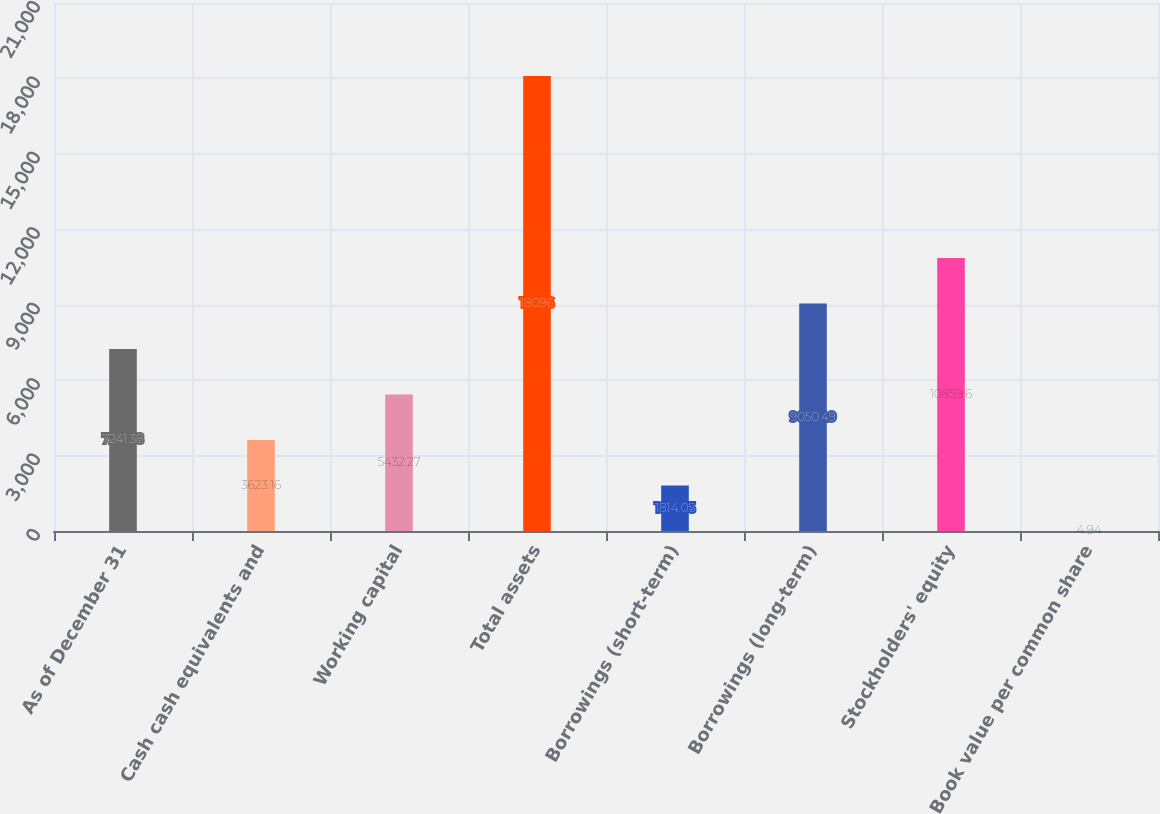Convert chart to OTSL. <chart><loc_0><loc_0><loc_500><loc_500><bar_chart><fcel>As of December 31<fcel>Cash cash equivalents and<fcel>Working capital<fcel>Total assets<fcel>Borrowings (short-term)<fcel>Borrowings (long-term)<fcel>Stockholders' equity<fcel>Book value per common share<nl><fcel>7241.38<fcel>3623.16<fcel>5432.27<fcel>18096<fcel>1814.05<fcel>9050.49<fcel>10859.6<fcel>4.94<nl></chart> 